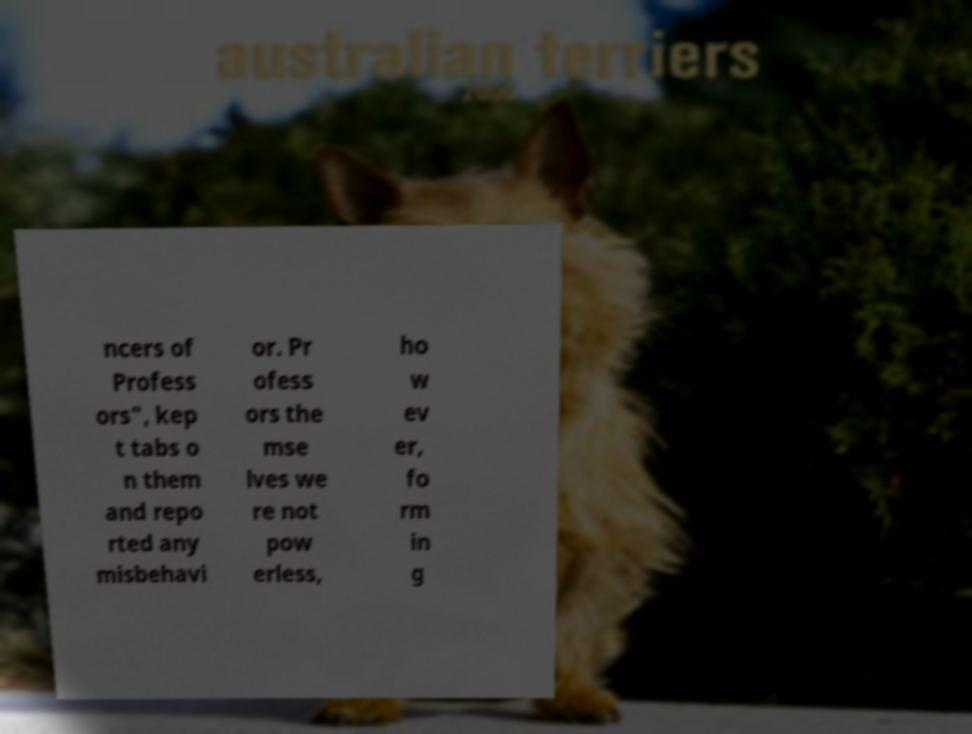What messages or text are displayed in this image? I need them in a readable, typed format. ncers of Profess ors", kep t tabs o n them and repo rted any misbehavi or. Pr ofess ors the mse lves we re not pow erless, ho w ev er, fo rm in g 